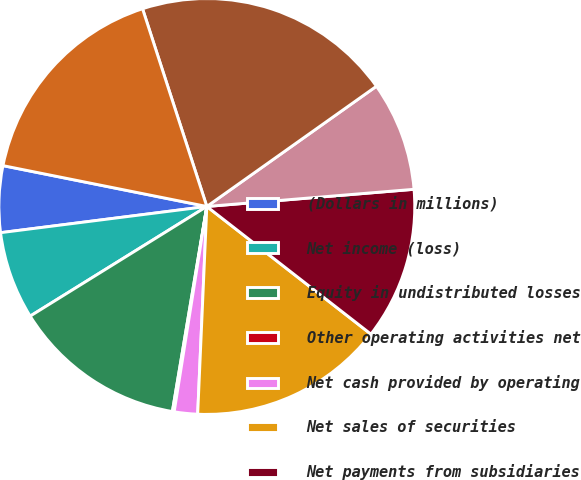Convert chart to OTSL. <chart><loc_0><loc_0><loc_500><loc_500><pie_chart><fcel>(Dollars in millions)<fcel>Net income (loss)<fcel>Equity in undistributed losses<fcel>Other operating activities net<fcel>Net cash provided by operating<fcel>Net sales of securities<fcel>Net payments from subsidiaries<fcel>Other investing activities net<fcel>Net cash provided by investing<fcel>Net increase (decrease) in<nl><fcel>5.16%<fcel>6.83%<fcel>13.51%<fcel>0.14%<fcel>1.81%<fcel>15.18%<fcel>11.84%<fcel>8.5%<fcel>20.19%<fcel>16.85%<nl></chart> 